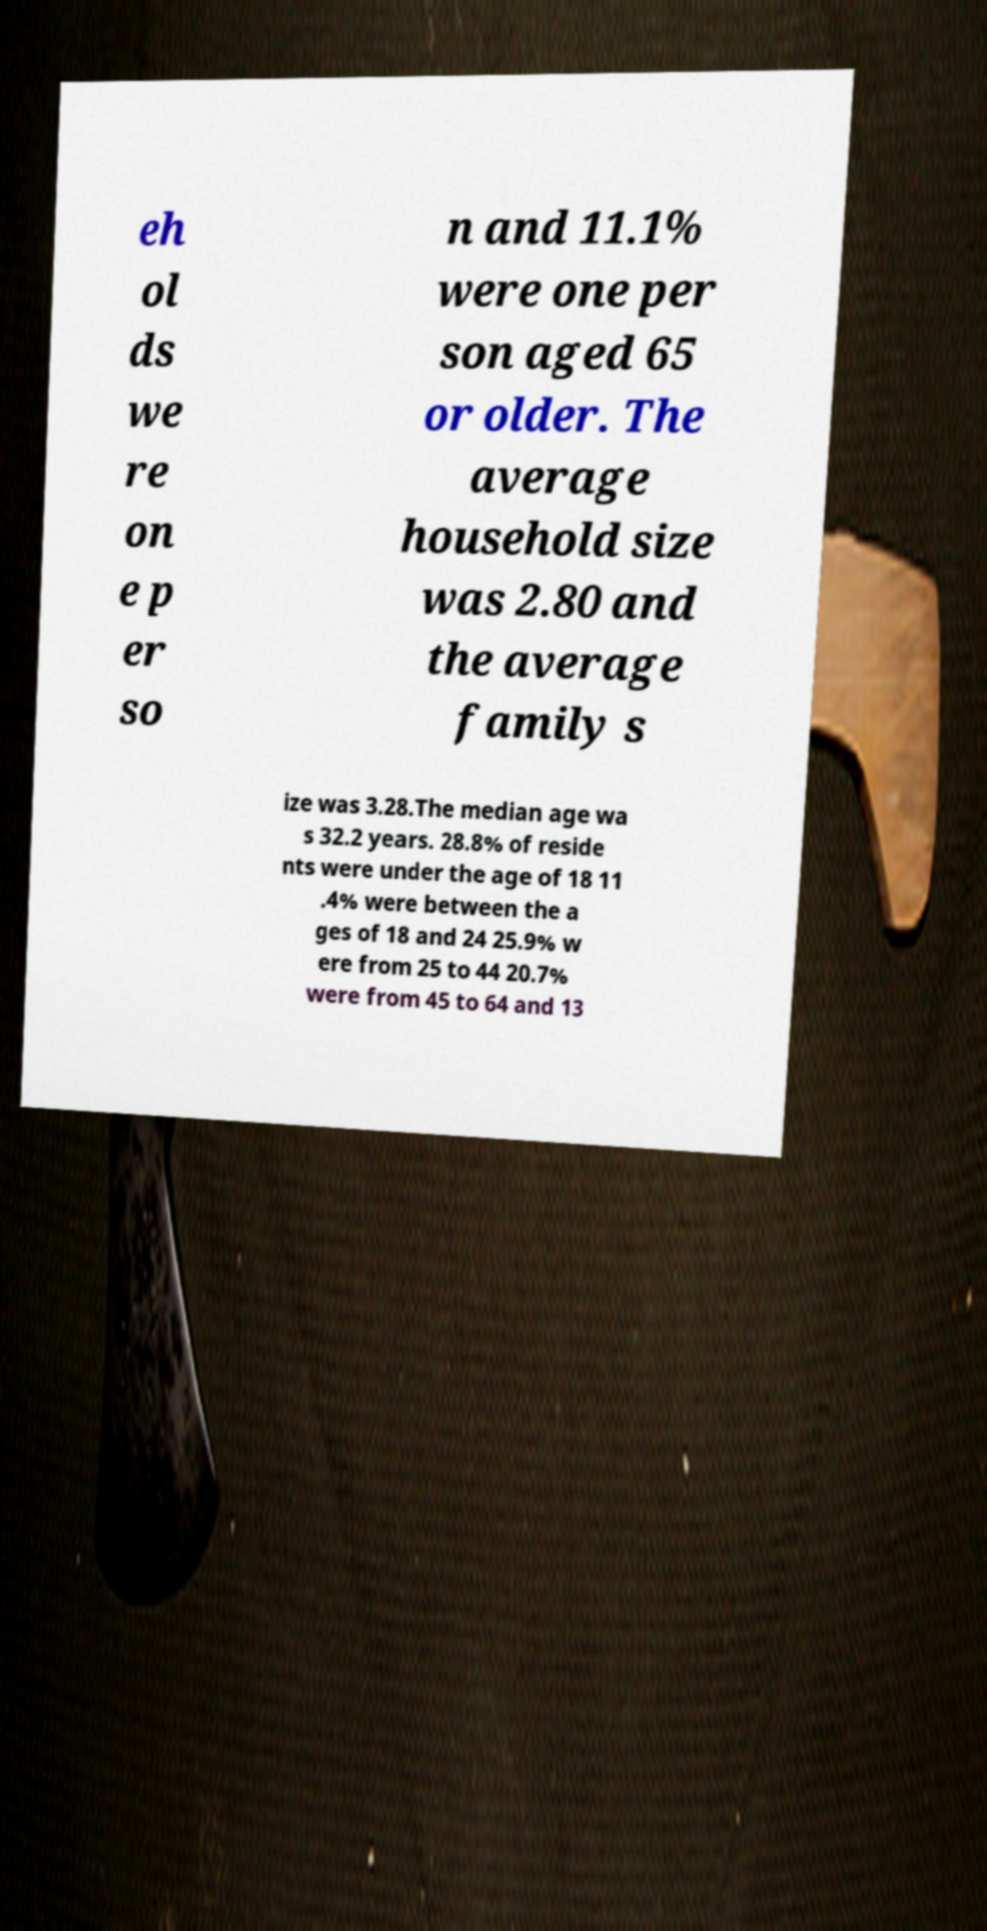Can you accurately transcribe the text from the provided image for me? eh ol ds we re on e p er so n and 11.1% were one per son aged 65 or older. The average household size was 2.80 and the average family s ize was 3.28.The median age wa s 32.2 years. 28.8% of reside nts were under the age of 18 11 .4% were between the a ges of 18 and 24 25.9% w ere from 25 to 44 20.7% were from 45 to 64 and 13 